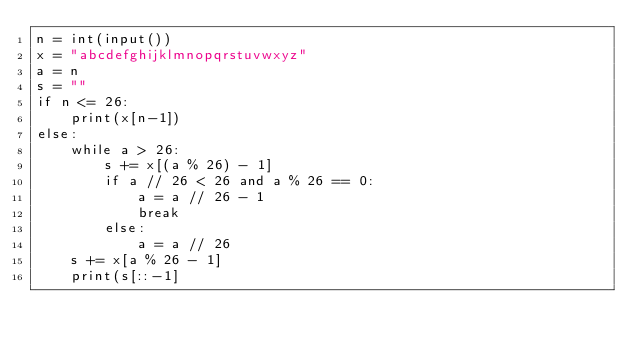Convert code to text. <code><loc_0><loc_0><loc_500><loc_500><_Python_>n = int(input())
x = "abcdefghijklmnopqrstuvwxyz"
a = n
s = ""
if n <= 26:
    print(x[n-1])
else:
    while a > 26:
        s += x[(a % 26) - 1]
        if a // 26 < 26 and a % 26 == 0:
            a = a // 26 - 1
            break
        else:
            a = a // 26
    s += x[a % 26 - 1]
    print(s[::-1]</code> 